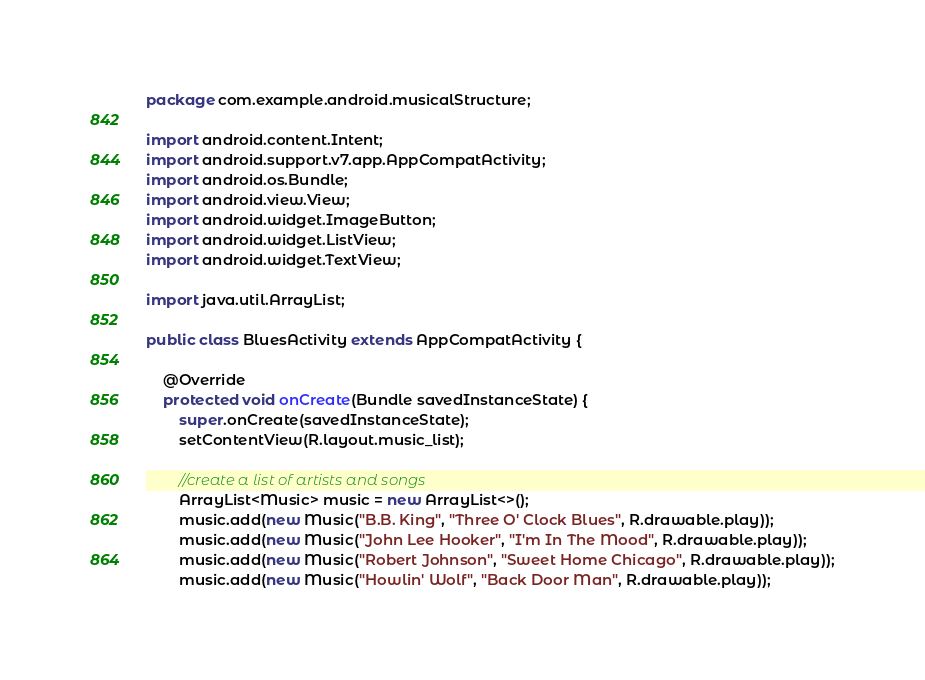<code> <loc_0><loc_0><loc_500><loc_500><_Java_>package com.example.android.musicalStructure;

import android.content.Intent;
import android.support.v7.app.AppCompatActivity;
import android.os.Bundle;
import android.view.View;
import android.widget.ImageButton;
import android.widget.ListView;
import android.widget.TextView;

import java.util.ArrayList;

public class BluesActivity extends AppCompatActivity {

    @Override
    protected void onCreate(Bundle savedInstanceState) {
        super.onCreate(savedInstanceState);
        setContentView(R.layout.music_list);

        //create a list of artists and songs
        ArrayList<Music> music = new ArrayList<>();
        music.add(new Music("B.B. King", "Three O' Clock Blues", R.drawable.play));
        music.add(new Music("John Lee Hooker", "I'm In The Mood", R.drawable.play));
        music.add(new Music("Robert Johnson", "Sweet Home Chicago", R.drawable.play));
        music.add(new Music("Howlin' Wolf", "Back Door Man", R.drawable.play));</code> 